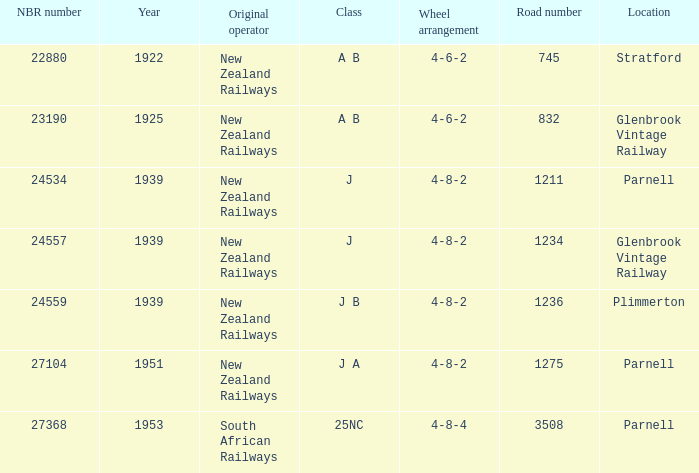How many road numbers are before 1922? 0.0. Help me parse the entirety of this table. {'header': ['NBR number', 'Year', 'Original operator', 'Class', 'Wheel arrangement', 'Road number', 'Location'], 'rows': [['22880', '1922', 'New Zealand Railways', 'A B', '4-6-2', '745', 'Stratford'], ['23190', '1925', 'New Zealand Railways', 'A B', '4-6-2', '832', 'Glenbrook Vintage Railway'], ['24534', '1939', 'New Zealand Railways', 'J', '4-8-2', '1211', 'Parnell'], ['24557', '1939', 'New Zealand Railways', 'J', '4-8-2', '1234', 'Glenbrook Vintage Railway'], ['24559', '1939', 'New Zealand Railways', 'J B', '4-8-2', '1236', 'Plimmerton'], ['27104', '1951', 'New Zealand Railways', 'J A', '4-8-2', '1275', 'Parnell'], ['27368', '1953', 'South African Railways', '25NC', '4-8-4', '3508', 'Parnell']]} 